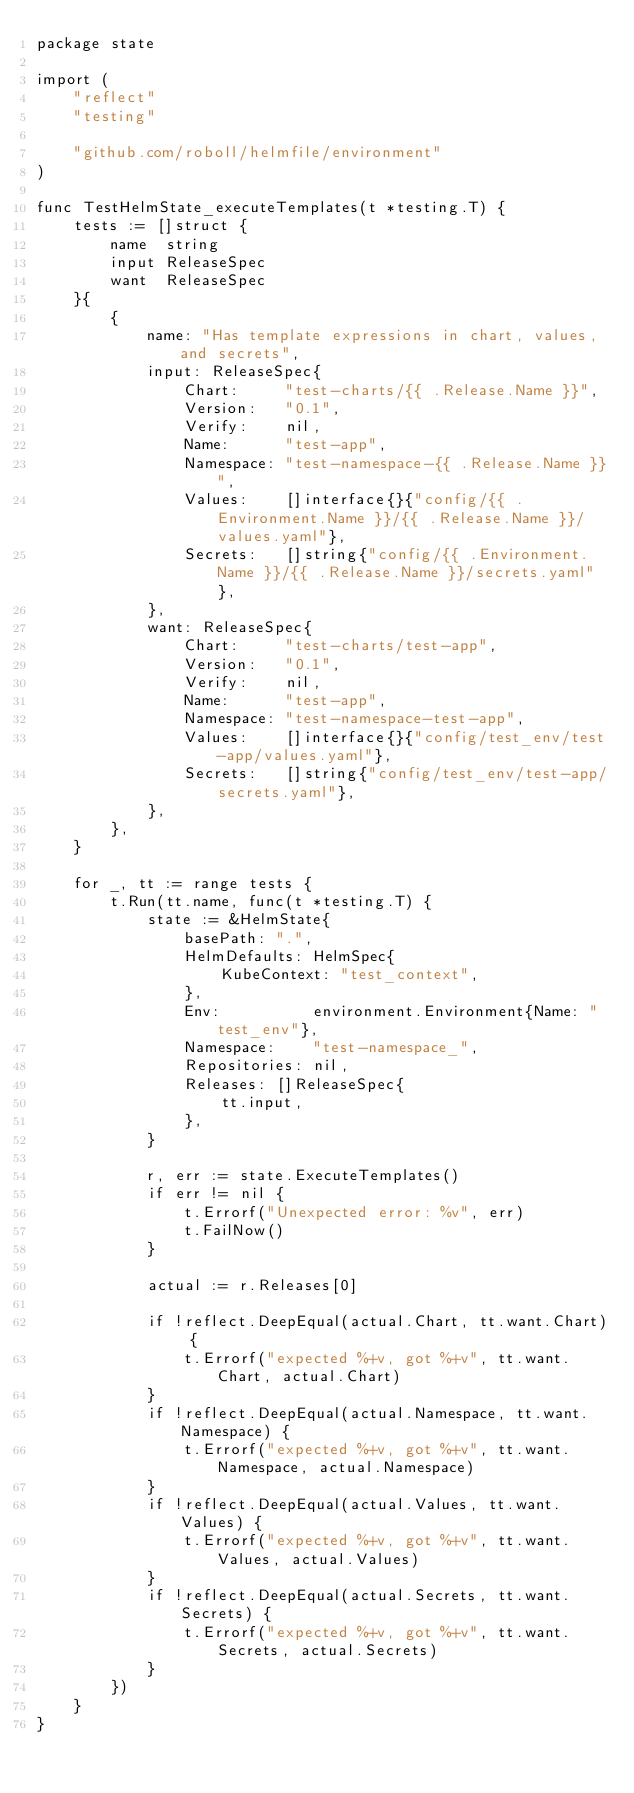<code> <loc_0><loc_0><loc_500><loc_500><_Go_>package state

import (
	"reflect"
	"testing"

	"github.com/roboll/helmfile/environment"
)

func TestHelmState_executeTemplates(t *testing.T) {
	tests := []struct {
		name  string
		input ReleaseSpec
		want  ReleaseSpec
	}{
		{
			name: "Has template expressions in chart, values, and secrets",
			input: ReleaseSpec{
				Chart:     "test-charts/{{ .Release.Name }}",
				Version:   "0.1",
				Verify:    nil,
				Name:      "test-app",
				Namespace: "test-namespace-{{ .Release.Name }}",
				Values:    []interface{}{"config/{{ .Environment.Name }}/{{ .Release.Name }}/values.yaml"},
				Secrets:   []string{"config/{{ .Environment.Name }}/{{ .Release.Name }}/secrets.yaml"},
			},
			want: ReleaseSpec{
				Chart:     "test-charts/test-app",
				Version:   "0.1",
				Verify:    nil,
				Name:      "test-app",
				Namespace: "test-namespace-test-app",
				Values:    []interface{}{"config/test_env/test-app/values.yaml"},
				Secrets:   []string{"config/test_env/test-app/secrets.yaml"},
			},
		},
	}

	for _, tt := range tests {
		t.Run(tt.name, func(t *testing.T) {
			state := &HelmState{
				basePath: ".",
				HelmDefaults: HelmSpec{
					KubeContext: "test_context",
				},
				Env:          environment.Environment{Name: "test_env"},
				Namespace:    "test-namespace_",
				Repositories: nil,
				Releases: []ReleaseSpec{
					tt.input,
				},
			}

			r, err := state.ExecuteTemplates()
			if err != nil {
				t.Errorf("Unexpected error: %v", err)
				t.FailNow()
			}

			actual := r.Releases[0]

			if !reflect.DeepEqual(actual.Chart, tt.want.Chart) {
				t.Errorf("expected %+v, got %+v", tt.want.Chart, actual.Chart)
			}
			if !reflect.DeepEqual(actual.Namespace, tt.want.Namespace) {
				t.Errorf("expected %+v, got %+v", tt.want.Namespace, actual.Namespace)
			}
			if !reflect.DeepEqual(actual.Values, tt.want.Values) {
				t.Errorf("expected %+v, got %+v", tt.want.Values, actual.Values)
			}
			if !reflect.DeepEqual(actual.Secrets, tt.want.Secrets) {
				t.Errorf("expected %+v, got %+v", tt.want.Secrets, actual.Secrets)
			}
		})
	}
}
</code> 